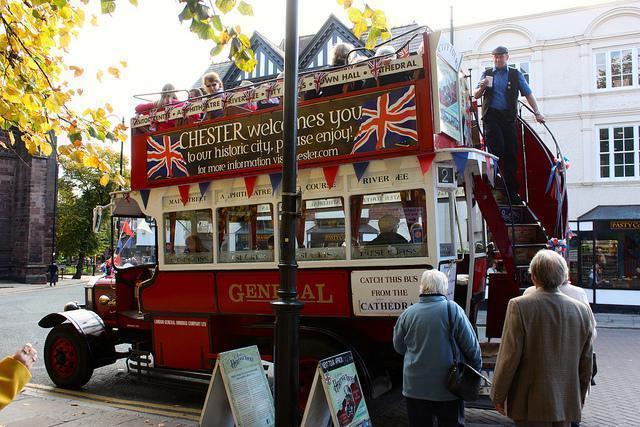The flag on the bus belongs to which Country?
Answer the question by selecting the correct answer among the 4 following choices and explain your choice with a short sentence. The answer should be formatted with the following format: `Answer: choice
Rationale: rationale.`
Options: United states, united kingdom, switzerland, brazil. Answer: united kingdom.
Rationale: The red, white, and blue flag is the union jack. 